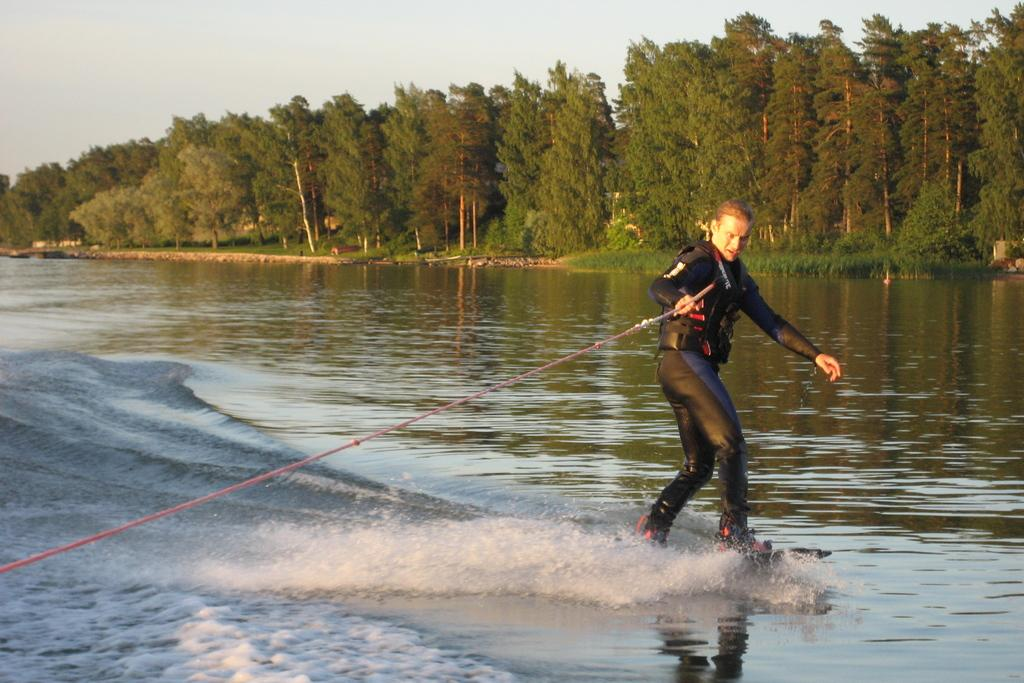What is the main subject of the image? There is a person in the image. What is the person wearing? The person is wearing a black dress. What activity is the person engaged in? The person is surfing on water. What is the person holding in their hands? The person is holding a rope in their hands. What can be seen in the background of the image? There are trees and a clear sky in the background of the image. How much was the payment for the quiet time after the surfing session? There is no mention of payment or quiet time in the image, as it focuses on a person surfing on water while holding a rope. 